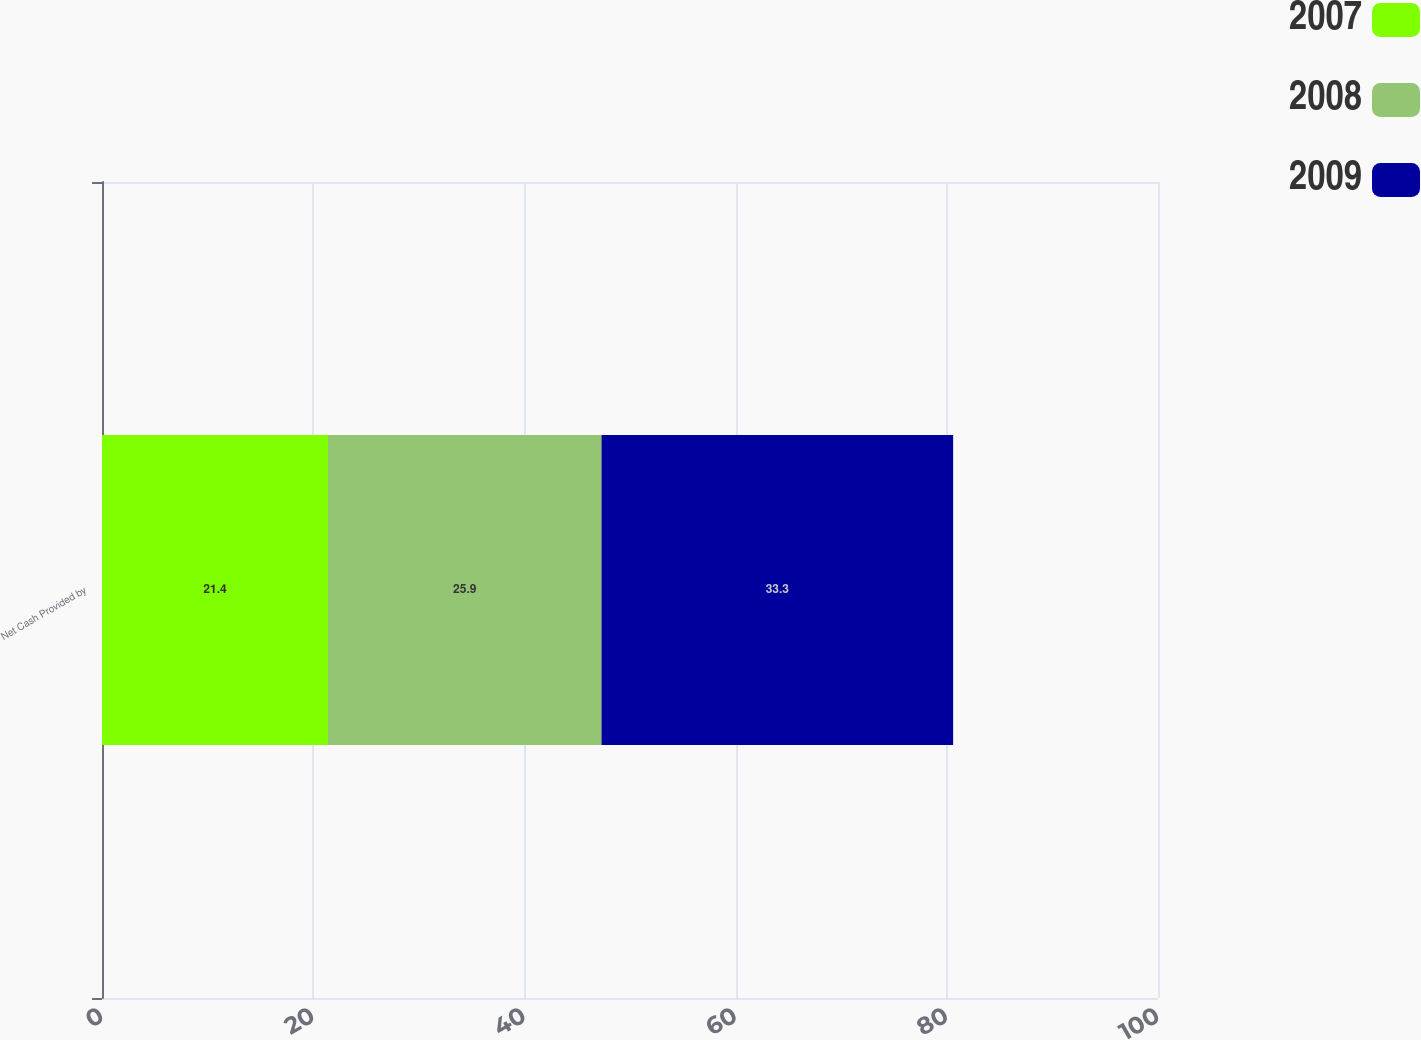Convert chart. <chart><loc_0><loc_0><loc_500><loc_500><stacked_bar_chart><ecel><fcel>Net Cash Provided by<nl><fcel>2007<fcel>21.4<nl><fcel>2008<fcel>25.9<nl><fcel>2009<fcel>33.3<nl></chart> 